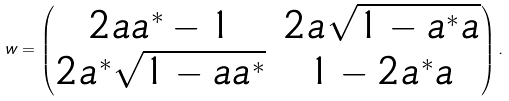Convert formula to latex. <formula><loc_0><loc_0><loc_500><loc_500>w = \begin{pmatrix} 2 a a ^ { * } - 1 & 2 a \sqrt { 1 - a ^ { * } a } \\ 2 a ^ { * } \sqrt { 1 - a a ^ { * } } & 1 - 2 a ^ { * } a \end{pmatrix} .</formula> 